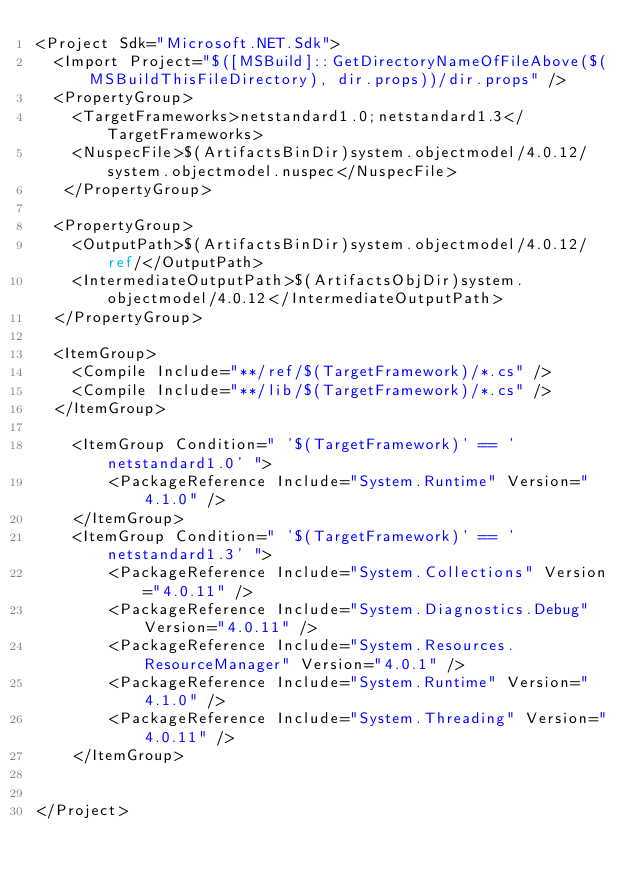<code> <loc_0><loc_0><loc_500><loc_500><_XML_><Project Sdk="Microsoft.NET.Sdk">
  <Import Project="$([MSBuild]::GetDirectoryNameOfFileAbove($(MSBuildThisFileDirectory), dir.props))/dir.props" />
  <PropertyGroup>
    <TargetFrameworks>netstandard1.0;netstandard1.3</TargetFrameworks>
    <NuspecFile>$(ArtifactsBinDir)system.objectmodel/4.0.12/system.objectmodel.nuspec</NuspecFile>
   </PropertyGroup>

  <PropertyGroup>
    <OutputPath>$(ArtifactsBinDir)system.objectmodel/4.0.12/ref/</OutputPath>
    <IntermediateOutputPath>$(ArtifactsObjDir)system.objectmodel/4.0.12</IntermediateOutputPath>
  </PropertyGroup>

  <ItemGroup>
    <Compile Include="**/ref/$(TargetFramework)/*.cs" />
    <Compile Include="**/lib/$(TargetFramework)/*.cs" />
  </ItemGroup>

    <ItemGroup Condition=" '$(TargetFramework)' == 'netstandard1.0' ">
        <PackageReference Include="System.Runtime" Version="4.1.0" />
    </ItemGroup>
    <ItemGroup Condition=" '$(TargetFramework)' == 'netstandard1.3' ">
        <PackageReference Include="System.Collections" Version="4.0.11" />
        <PackageReference Include="System.Diagnostics.Debug" Version="4.0.11" />
        <PackageReference Include="System.Resources.ResourceManager" Version="4.0.1" />
        <PackageReference Include="System.Runtime" Version="4.1.0" />
        <PackageReference Include="System.Threading" Version="4.0.11" />
    </ItemGroup>

  
</Project>
</code> 